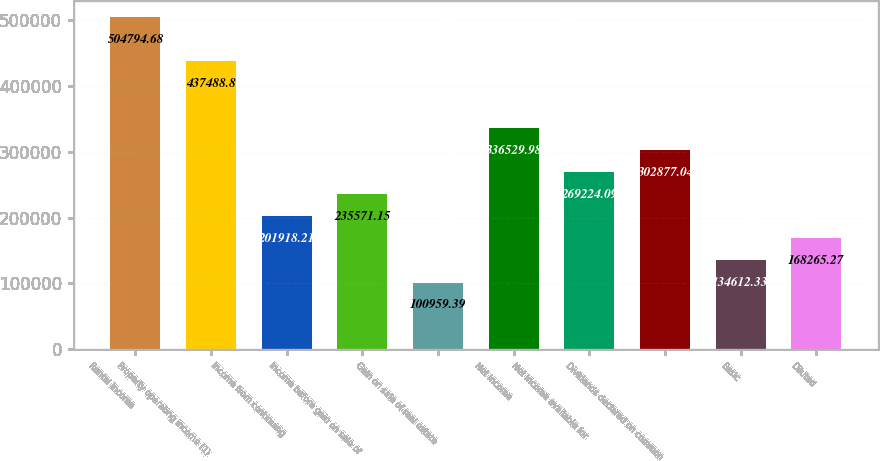<chart> <loc_0><loc_0><loc_500><loc_500><bar_chart><fcel>Rental income<fcel>Property operating income (1)<fcel>Income from continuing<fcel>Income before gain on sale of<fcel>Gain on sale of real estate<fcel>Net income<fcel>Net income available for<fcel>Dividends declared on common<fcel>Basic<fcel>Diluted<nl><fcel>504795<fcel>437489<fcel>201918<fcel>235571<fcel>100959<fcel>336530<fcel>269224<fcel>302877<fcel>134612<fcel>168265<nl></chart> 